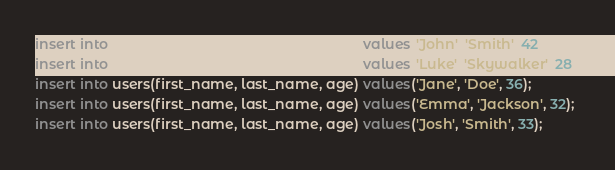Convert code to text. <code><loc_0><loc_0><loc_500><loc_500><_SQL_>insert into users(first_name, last_name, age) values('John', 'Smith', 42);
insert into users(first_name, last_name, age) values('Luke', 'Skywalker', 28);
insert into users(first_name, last_name, age) values('Jane', 'Doe', 36);
insert into users(first_name, last_name, age) values('Emma', 'Jackson', 32);
insert into users(first_name, last_name, age) values('Josh', 'Smith', 33);</code> 